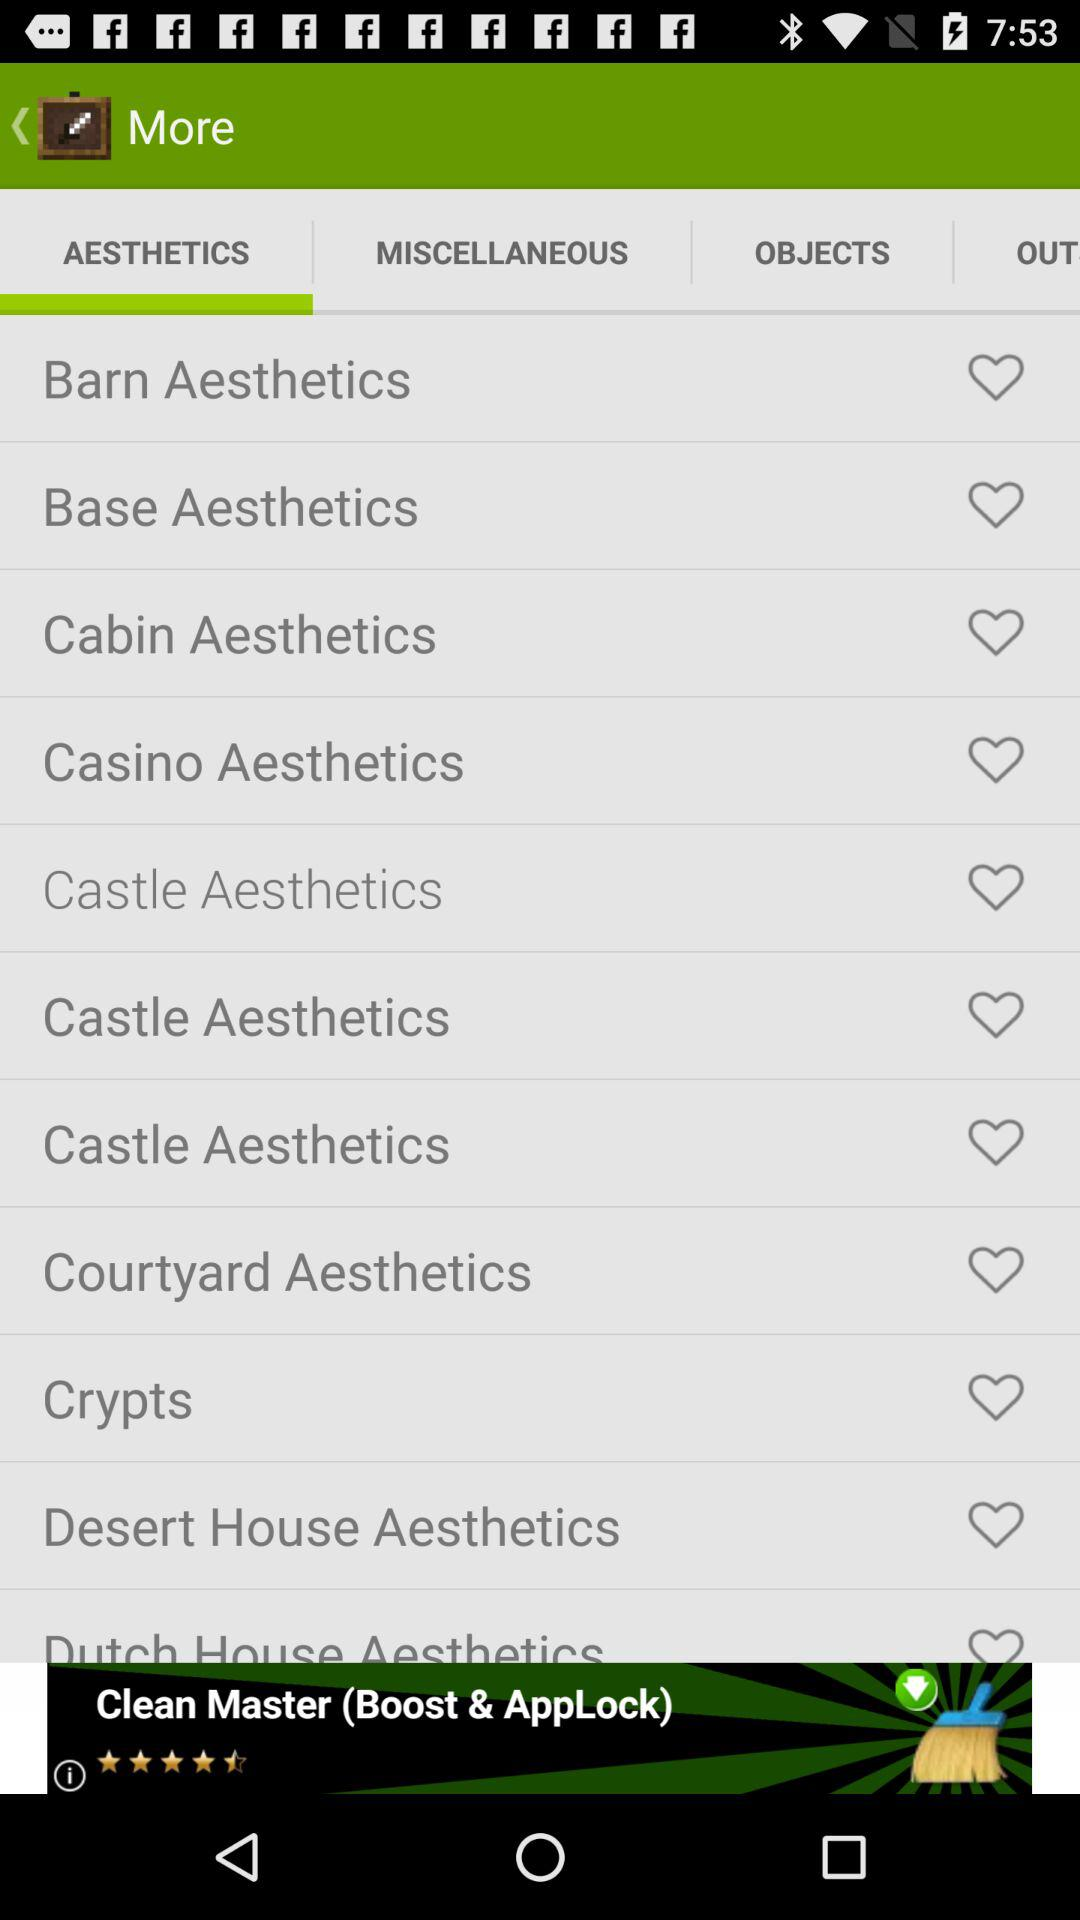How many aesthetics are there in total?
Answer the question using a single word or phrase. 10 